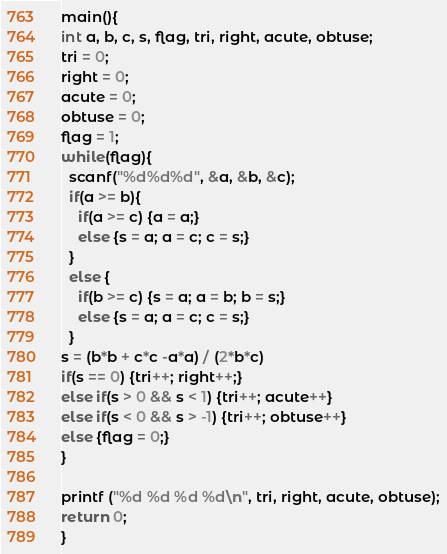Convert code to text. <code><loc_0><loc_0><loc_500><loc_500><_C_>main(){
int a, b, c, s, flag, tri, right, acute, obtuse;
tri = 0;
right = 0;
acute = 0;
obtuse = 0;
flag = 1;
while(flag){
  scanf("%d%d%d", &a, &b, &c);
  if(a >= b){
    if(a >= c) {a = a;}
    else {s = a; a = c; c = s;}
  }
  else {
    if(b >= c) {s = a; a = b; b = s;}
    else {s = a; a = c; c = s;}
  }
s = (b*b + c*c -a*a) / (2*b*c)
if(s == 0) {tri++; right++;}
else if(s > 0 && s < 1) {tri++; acute++}
else if(s < 0 && s > -1) {tri++; obtuse++}
else {flag = 0;}
}

printf ("%d %d %d %d\n", tri, right, acute, obtuse);
return 0;
}

</code> 